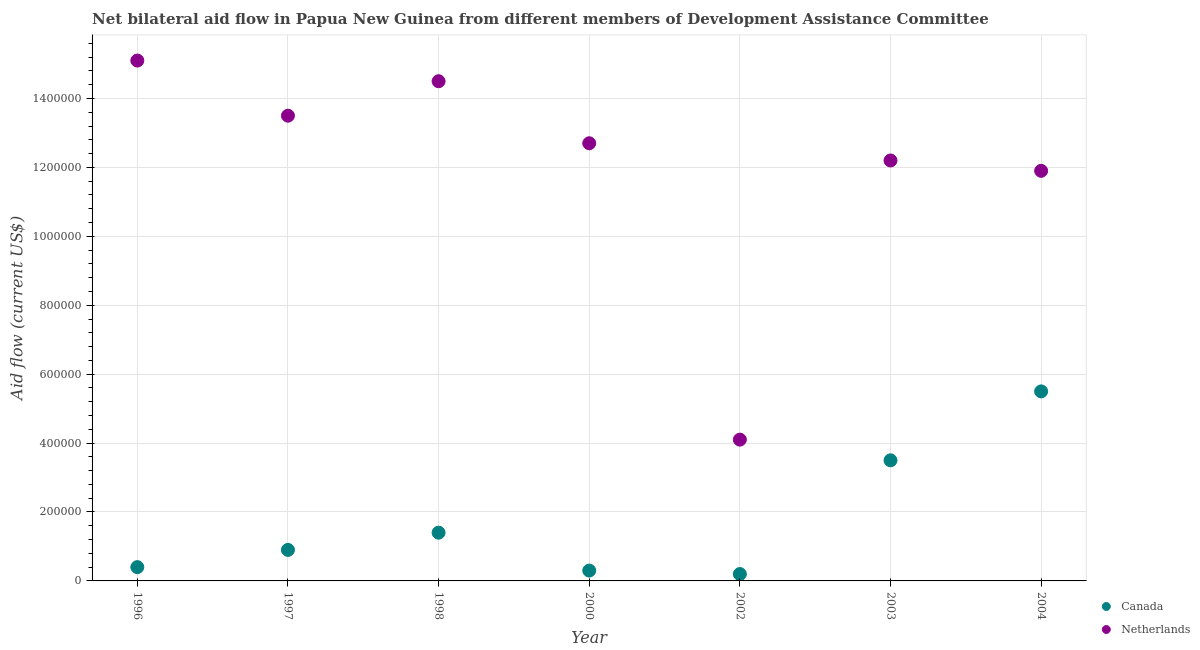How many different coloured dotlines are there?
Your answer should be compact. 2. What is the amount of aid given by netherlands in 2000?
Ensure brevity in your answer.  1.27e+06. Across all years, what is the maximum amount of aid given by netherlands?
Provide a succinct answer. 1.51e+06. Across all years, what is the minimum amount of aid given by netherlands?
Your answer should be compact. 4.10e+05. In which year was the amount of aid given by canada minimum?
Your answer should be very brief. 2002. What is the total amount of aid given by canada in the graph?
Your answer should be very brief. 1.22e+06. What is the difference between the amount of aid given by canada in 2000 and that in 2004?
Make the answer very short. -5.20e+05. What is the difference between the amount of aid given by canada in 1998 and the amount of aid given by netherlands in 1996?
Keep it short and to the point. -1.37e+06. What is the average amount of aid given by canada per year?
Your response must be concise. 1.74e+05. In the year 1998, what is the difference between the amount of aid given by canada and amount of aid given by netherlands?
Provide a short and direct response. -1.31e+06. In how many years, is the amount of aid given by canada greater than 1120000 US$?
Provide a short and direct response. 0. What is the ratio of the amount of aid given by canada in 1996 to that in 1997?
Offer a very short reply. 0.44. Is the amount of aid given by netherlands in 1998 less than that in 2000?
Your answer should be very brief. No. What is the difference between the highest and the second highest amount of aid given by netherlands?
Your answer should be very brief. 6.00e+04. What is the difference between the highest and the lowest amount of aid given by canada?
Offer a terse response. 5.30e+05. In how many years, is the amount of aid given by netherlands greater than the average amount of aid given by netherlands taken over all years?
Ensure brevity in your answer.  5. Is the sum of the amount of aid given by netherlands in 1996 and 2003 greater than the maximum amount of aid given by canada across all years?
Your answer should be compact. Yes. Is the amount of aid given by canada strictly greater than the amount of aid given by netherlands over the years?
Your answer should be very brief. No. What is the difference between two consecutive major ticks on the Y-axis?
Provide a short and direct response. 2.00e+05. Are the values on the major ticks of Y-axis written in scientific E-notation?
Offer a terse response. No. What is the title of the graph?
Ensure brevity in your answer.  Net bilateral aid flow in Papua New Guinea from different members of Development Assistance Committee. What is the label or title of the Y-axis?
Your response must be concise. Aid flow (current US$). What is the Aid flow (current US$) of Canada in 1996?
Offer a very short reply. 4.00e+04. What is the Aid flow (current US$) in Netherlands in 1996?
Offer a terse response. 1.51e+06. What is the Aid flow (current US$) in Netherlands in 1997?
Offer a very short reply. 1.35e+06. What is the Aid flow (current US$) of Netherlands in 1998?
Your answer should be very brief. 1.45e+06. What is the Aid flow (current US$) of Netherlands in 2000?
Your answer should be very brief. 1.27e+06. What is the Aid flow (current US$) of Netherlands in 2002?
Provide a short and direct response. 4.10e+05. What is the Aid flow (current US$) in Netherlands in 2003?
Ensure brevity in your answer.  1.22e+06. What is the Aid flow (current US$) in Canada in 2004?
Your answer should be very brief. 5.50e+05. What is the Aid flow (current US$) of Netherlands in 2004?
Give a very brief answer. 1.19e+06. Across all years, what is the maximum Aid flow (current US$) of Canada?
Ensure brevity in your answer.  5.50e+05. Across all years, what is the maximum Aid flow (current US$) of Netherlands?
Your answer should be very brief. 1.51e+06. Across all years, what is the minimum Aid flow (current US$) of Netherlands?
Provide a succinct answer. 4.10e+05. What is the total Aid flow (current US$) of Canada in the graph?
Provide a succinct answer. 1.22e+06. What is the total Aid flow (current US$) in Netherlands in the graph?
Give a very brief answer. 8.40e+06. What is the difference between the Aid flow (current US$) of Canada in 1996 and that in 1997?
Your answer should be very brief. -5.00e+04. What is the difference between the Aid flow (current US$) in Netherlands in 1996 and that in 1997?
Give a very brief answer. 1.60e+05. What is the difference between the Aid flow (current US$) of Netherlands in 1996 and that in 1998?
Provide a succinct answer. 6.00e+04. What is the difference between the Aid flow (current US$) of Netherlands in 1996 and that in 2000?
Ensure brevity in your answer.  2.40e+05. What is the difference between the Aid flow (current US$) of Canada in 1996 and that in 2002?
Keep it short and to the point. 2.00e+04. What is the difference between the Aid flow (current US$) in Netherlands in 1996 and that in 2002?
Ensure brevity in your answer.  1.10e+06. What is the difference between the Aid flow (current US$) in Canada in 1996 and that in 2003?
Give a very brief answer. -3.10e+05. What is the difference between the Aid flow (current US$) in Canada in 1996 and that in 2004?
Make the answer very short. -5.10e+05. What is the difference between the Aid flow (current US$) of Netherlands in 1996 and that in 2004?
Provide a short and direct response. 3.20e+05. What is the difference between the Aid flow (current US$) in Canada in 1997 and that in 1998?
Your response must be concise. -5.00e+04. What is the difference between the Aid flow (current US$) of Netherlands in 1997 and that in 1998?
Offer a very short reply. -1.00e+05. What is the difference between the Aid flow (current US$) in Canada in 1997 and that in 2002?
Offer a very short reply. 7.00e+04. What is the difference between the Aid flow (current US$) of Netherlands in 1997 and that in 2002?
Provide a succinct answer. 9.40e+05. What is the difference between the Aid flow (current US$) of Canada in 1997 and that in 2004?
Offer a terse response. -4.60e+05. What is the difference between the Aid flow (current US$) of Netherlands in 1997 and that in 2004?
Provide a succinct answer. 1.60e+05. What is the difference between the Aid flow (current US$) of Canada in 1998 and that in 2002?
Ensure brevity in your answer.  1.20e+05. What is the difference between the Aid flow (current US$) of Netherlands in 1998 and that in 2002?
Provide a succinct answer. 1.04e+06. What is the difference between the Aid flow (current US$) of Netherlands in 1998 and that in 2003?
Ensure brevity in your answer.  2.30e+05. What is the difference between the Aid flow (current US$) of Canada in 1998 and that in 2004?
Provide a short and direct response. -4.10e+05. What is the difference between the Aid flow (current US$) in Netherlands in 1998 and that in 2004?
Your response must be concise. 2.60e+05. What is the difference between the Aid flow (current US$) in Netherlands in 2000 and that in 2002?
Ensure brevity in your answer.  8.60e+05. What is the difference between the Aid flow (current US$) of Canada in 2000 and that in 2003?
Your answer should be compact. -3.20e+05. What is the difference between the Aid flow (current US$) of Canada in 2000 and that in 2004?
Offer a terse response. -5.20e+05. What is the difference between the Aid flow (current US$) in Canada in 2002 and that in 2003?
Offer a terse response. -3.30e+05. What is the difference between the Aid flow (current US$) of Netherlands in 2002 and that in 2003?
Your response must be concise. -8.10e+05. What is the difference between the Aid flow (current US$) of Canada in 2002 and that in 2004?
Make the answer very short. -5.30e+05. What is the difference between the Aid flow (current US$) in Netherlands in 2002 and that in 2004?
Offer a very short reply. -7.80e+05. What is the difference between the Aid flow (current US$) in Canada in 1996 and the Aid flow (current US$) in Netherlands in 1997?
Ensure brevity in your answer.  -1.31e+06. What is the difference between the Aid flow (current US$) of Canada in 1996 and the Aid flow (current US$) of Netherlands in 1998?
Your answer should be very brief. -1.41e+06. What is the difference between the Aid flow (current US$) in Canada in 1996 and the Aid flow (current US$) in Netherlands in 2000?
Offer a terse response. -1.23e+06. What is the difference between the Aid flow (current US$) of Canada in 1996 and the Aid flow (current US$) of Netherlands in 2002?
Ensure brevity in your answer.  -3.70e+05. What is the difference between the Aid flow (current US$) of Canada in 1996 and the Aid flow (current US$) of Netherlands in 2003?
Your answer should be very brief. -1.18e+06. What is the difference between the Aid flow (current US$) in Canada in 1996 and the Aid flow (current US$) in Netherlands in 2004?
Your answer should be compact. -1.15e+06. What is the difference between the Aid flow (current US$) in Canada in 1997 and the Aid flow (current US$) in Netherlands in 1998?
Your response must be concise. -1.36e+06. What is the difference between the Aid flow (current US$) in Canada in 1997 and the Aid flow (current US$) in Netherlands in 2000?
Offer a very short reply. -1.18e+06. What is the difference between the Aid flow (current US$) of Canada in 1997 and the Aid flow (current US$) of Netherlands in 2002?
Your answer should be compact. -3.20e+05. What is the difference between the Aid flow (current US$) of Canada in 1997 and the Aid flow (current US$) of Netherlands in 2003?
Offer a terse response. -1.13e+06. What is the difference between the Aid flow (current US$) in Canada in 1997 and the Aid flow (current US$) in Netherlands in 2004?
Your answer should be very brief. -1.10e+06. What is the difference between the Aid flow (current US$) in Canada in 1998 and the Aid flow (current US$) in Netherlands in 2000?
Provide a short and direct response. -1.13e+06. What is the difference between the Aid flow (current US$) in Canada in 1998 and the Aid flow (current US$) in Netherlands in 2002?
Your answer should be very brief. -2.70e+05. What is the difference between the Aid flow (current US$) of Canada in 1998 and the Aid flow (current US$) of Netherlands in 2003?
Ensure brevity in your answer.  -1.08e+06. What is the difference between the Aid flow (current US$) of Canada in 1998 and the Aid flow (current US$) of Netherlands in 2004?
Your answer should be compact. -1.05e+06. What is the difference between the Aid flow (current US$) in Canada in 2000 and the Aid flow (current US$) in Netherlands in 2002?
Give a very brief answer. -3.80e+05. What is the difference between the Aid flow (current US$) in Canada in 2000 and the Aid flow (current US$) in Netherlands in 2003?
Make the answer very short. -1.19e+06. What is the difference between the Aid flow (current US$) of Canada in 2000 and the Aid flow (current US$) of Netherlands in 2004?
Make the answer very short. -1.16e+06. What is the difference between the Aid flow (current US$) in Canada in 2002 and the Aid flow (current US$) in Netherlands in 2003?
Offer a terse response. -1.20e+06. What is the difference between the Aid flow (current US$) of Canada in 2002 and the Aid flow (current US$) of Netherlands in 2004?
Your answer should be compact. -1.17e+06. What is the difference between the Aid flow (current US$) in Canada in 2003 and the Aid flow (current US$) in Netherlands in 2004?
Offer a very short reply. -8.40e+05. What is the average Aid flow (current US$) in Canada per year?
Your answer should be compact. 1.74e+05. What is the average Aid flow (current US$) of Netherlands per year?
Provide a short and direct response. 1.20e+06. In the year 1996, what is the difference between the Aid flow (current US$) of Canada and Aid flow (current US$) of Netherlands?
Your response must be concise. -1.47e+06. In the year 1997, what is the difference between the Aid flow (current US$) in Canada and Aid flow (current US$) in Netherlands?
Provide a short and direct response. -1.26e+06. In the year 1998, what is the difference between the Aid flow (current US$) in Canada and Aid flow (current US$) in Netherlands?
Offer a very short reply. -1.31e+06. In the year 2000, what is the difference between the Aid flow (current US$) of Canada and Aid flow (current US$) of Netherlands?
Your answer should be compact. -1.24e+06. In the year 2002, what is the difference between the Aid flow (current US$) in Canada and Aid flow (current US$) in Netherlands?
Provide a succinct answer. -3.90e+05. In the year 2003, what is the difference between the Aid flow (current US$) in Canada and Aid flow (current US$) in Netherlands?
Your response must be concise. -8.70e+05. In the year 2004, what is the difference between the Aid flow (current US$) of Canada and Aid flow (current US$) of Netherlands?
Keep it short and to the point. -6.40e+05. What is the ratio of the Aid flow (current US$) of Canada in 1996 to that in 1997?
Provide a short and direct response. 0.44. What is the ratio of the Aid flow (current US$) of Netherlands in 1996 to that in 1997?
Your answer should be compact. 1.12. What is the ratio of the Aid flow (current US$) of Canada in 1996 to that in 1998?
Your response must be concise. 0.29. What is the ratio of the Aid flow (current US$) in Netherlands in 1996 to that in 1998?
Your answer should be compact. 1.04. What is the ratio of the Aid flow (current US$) in Canada in 1996 to that in 2000?
Offer a very short reply. 1.33. What is the ratio of the Aid flow (current US$) in Netherlands in 1996 to that in 2000?
Offer a very short reply. 1.19. What is the ratio of the Aid flow (current US$) of Canada in 1996 to that in 2002?
Provide a short and direct response. 2. What is the ratio of the Aid flow (current US$) of Netherlands in 1996 to that in 2002?
Keep it short and to the point. 3.68. What is the ratio of the Aid flow (current US$) in Canada in 1996 to that in 2003?
Your response must be concise. 0.11. What is the ratio of the Aid flow (current US$) in Netherlands in 1996 to that in 2003?
Keep it short and to the point. 1.24. What is the ratio of the Aid flow (current US$) in Canada in 1996 to that in 2004?
Your answer should be compact. 0.07. What is the ratio of the Aid flow (current US$) of Netherlands in 1996 to that in 2004?
Keep it short and to the point. 1.27. What is the ratio of the Aid flow (current US$) of Canada in 1997 to that in 1998?
Ensure brevity in your answer.  0.64. What is the ratio of the Aid flow (current US$) of Netherlands in 1997 to that in 1998?
Make the answer very short. 0.93. What is the ratio of the Aid flow (current US$) of Canada in 1997 to that in 2000?
Give a very brief answer. 3. What is the ratio of the Aid flow (current US$) of Netherlands in 1997 to that in 2000?
Ensure brevity in your answer.  1.06. What is the ratio of the Aid flow (current US$) of Netherlands in 1997 to that in 2002?
Provide a short and direct response. 3.29. What is the ratio of the Aid flow (current US$) of Canada in 1997 to that in 2003?
Ensure brevity in your answer.  0.26. What is the ratio of the Aid flow (current US$) in Netherlands in 1997 to that in 2003?
Provide a short and direct response. 1.11. What is the ratio of the Aid flow (current US$) in Canada in 1997 to that in 2004?
Ensure brevity in your answer.  0.16. What is the ratio of the Aid flow (current US$) in Netherlands in 1997 to that in 2004?
Offer a very short reply. 1.13. What is the ratio of the Aid flow (current US$) of Canada in 1998 to that in 2000?
Keep it short and to the point. 4.67. What is the ratio of the Aid flow (current US$) of Netherlands in 1998 to that in 2000?
Give a very brief answer. 1.14. What is the ratio of the Aid flow (current US$) in Netherlands in 1998 to that in 2002?
Your response must be concise. 3.54. What is the ratio of the Aid flow (current US$) in Netherlands in 1998 to that in 2003?
Offer a terse response. 1.19. What is the ratio of the Aid flow (current US$) of Canada in 1998 to that in 2004?
Ensure brevity in your answer.  0.25. What is the ratio of the Aid flow (current US$) in Netherlands in 1998 to that in 2004?
Your response must be concise. 1.22. What is the ratio of the Aid flow (current US$) in Netherlands in 2000 to that in 2002?
Give a very brief answer. 3.1. What is the ratio of the Aid flow (current US$) in Canada in 2000 to that in 2003?
Offer a very short reply. 0.09. What is the ratio of the Aid flow (current US$) in Netherlands in 2000 to that in 2003?
Make the answer very short. 1.04. What is the ratio of the Aid flow (current US$) of Canada in 2000 to that in 2004?
Offer a very short reply. 0.05. What is the ratio of the Aid flow (current US$) of Netherlands in 2000 to that in 2004?
Provide a succinct answer. 1.07. What is the ratio of the Aid flow (current US$) in Canada in 2002 to that in 2003?
Offer a very short reply. 0.06. What is the ratio of the Aid flow (current US$) of Netherlands in 2002 to that in 2003?
Offer a very short reply. 0.34. What is the ratio of the Aid flow (current US$) of Canada in 2002 to that in 2004?
Your answer should be compact. 0.04. What is the ratio of the Aid flow (current US$) of Netherlands in 2002 to that in 2004?
Offer a terse response. 0.34. What is the ratio of the Aid flow (current US$) in Canada in 2003 to that in 2004?
Your answer should be very brief. 0.64. What is the ratio of the Aid flow (current US$) in Netherlands in 2003 to that in 2004?
Offer a terse response. 1.03. What is the difference between the highest and the second highest Aid flow (current US$) in Canada?
Offer a very short reply. 2.00e+05. What is the difference between the highest and the lowest Aid flow (current US$) in Canada?
Your response must be concise. 5.30e+05. What is the difference between the highest and the lowest Aid flow (current US$) of Netherlands?
Make the answer very short. 1.10e+06. 